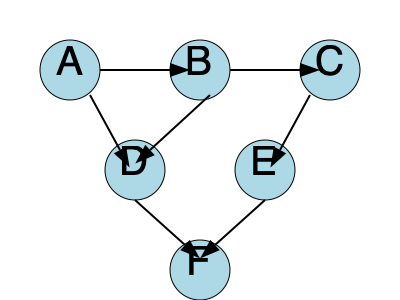Given the directed acyclic graph representing a microservices architecture, what is the maximum number of parallel service calls that can be made simultaneously, assuming each service takes an equal amount of time to process? To determine the maximum number of parallel service calls, we need to analyze the graph and identify the level with the most services that can be executed simultaneously. Let's break it down step-by-step:

1. Identify the levels in the graph:
   - Level 1: Service A (entry point)
   - Level 2: Services B and D
   - Level 3: Services C and E
   - Level 4: Service F (final service)

2. Analyze dependencies:
   - Service A must complete before B and D can start
   - Service B must complete before C can start
   - Services B and D must complete before E can start
   - Services C and E must complete before F can start

3. Determine parallel execution possibilities:
   - Level 1: Only A can execute (1 service)
   - Level 2: B and D can execute in parallel after A completes (2 services)
   - Level 3: C and E can execute in parallel after their dependencies are met (2 services)
   - Level 4: Only F can execute after all others complete (1 service)

4. Identify the maximum:
   The maximum number of services that can be executed in parallel is 2, which occurs at both Level 2 (B and D) and Level 3 (C and E).

Therefore, the maximum number of parallel service calls that can be made simultaneously is 2.
Answer: 2 